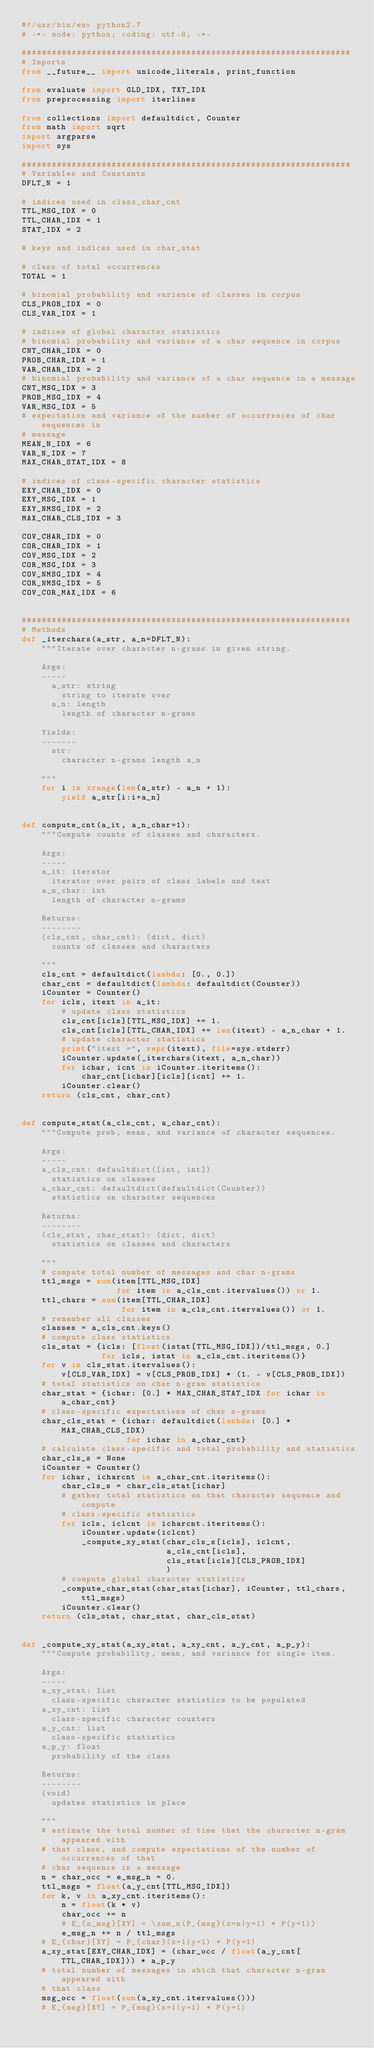<code> <loc_0><loc_0><loc_500><loc_500><_Python_>#!/usr/bin/env python2.7
# -*- mode: python; coding: utf-8; -*-

##################################################################
# Imports
from __future__ import unicode_literals, print_function

from evaluate import GLD_IDX, TXT_IDX
from preprocessing import iterlines

from collections import defaultdict, Counter
from math import sqrt
import argparse
import sys

##################################################################
# Variables and Constants
DFLT_N = 1

# indices used in class_char_cnt
TTL_MSG_IDX = 0
TTL_CHAR_IDX = 1
STAT_IDX = 2

# keys and indices used in char_stat

# class of total occurrences
TOTAL = 1

# binomial probability and variance of classes in corpus
CLS_PROB_IDX = 0
CLS_VAR_IDX = 1

# indices of global character statistics
# binomial probability and variance of a char sequence in corpus
CNT_CHAR_IDX = 0
PROB_CHAR_IDX = 1
VAR_CHAR_IDX = 2
# binomial probability and variance of a char sequence in a message
CNT_MSG_IDX = 3
PROB_MSG_IDX = 4
VAR_MSG_IDX = 5
# expectation and variance of the number of occurrences of char sequences in
# message
MEAN_N_IDX = 6
VAR_N_IDX = 7
MAX_CHAR_STAT_IDX = 8

# indices of class-specific character statistics
EXY_CHAR_IDX = 0
EXY_MSG_IDX = 1
EXY_NMSG_IDX = 2
MAX_CHAR_CLS_IDX = 3

COV_CHAR_IDX = 0
COR_CHAR_IDX = 1
COV_MSG_IDX = 2
COR_MSG_IDX = 3
COV_NMSG_IDX = 4
COR_NMSG_IDX = 5
COV_COR_MAX_IDX = 6


##################################################################
# Methods
def _iterchars(a_str, a_n=DFLT_N):
    """Iterate over character n-grams in given string.

    Args:
    -----
      a_str: string
        string to iterate over
      a_n: length
        length of character n-grams

    Yields:
    -------
      str:
        character n-grams length a_n

    """
    for i in xrange(len(a_str) - a_n + 1):
        yield a_str[i:i+a_n]


def compute_cnt(a_it, a_n_char=1):
    """Compute counts of classes and characters.

    Args:
    -----
    a_it: iterator
      iterator over pairs of class labels and text
    a_n_char: int
      length of character n-grams

    Returns:
    --------
    (cls_cnt, char_cnt): (dict, dict)
      counts of classes and characters

    """
    cls_cnt = defaultdict(lambda: [0., 0.])
    char_cnt = defaultdict(lambda: defaultdict(Counter))
    iCounter = Counter()
    for icls, itext in a_it:
        # update class statistics
        cls_cnt[icls][TTL_MSG_IDX] += 1.
        cls_cnt[icls][TTL_CHAR_IDX] += len(itext) - a_n_char + 1.
        # update character statistics
        print("itext =", repr(itext), file=sys.stderr)
        iCounter.update(_iterchars(itext, a_n_char))
        for ichar, icnt in iCounter.iteritems():
            char_cnt[ichar][icls][icnt] += 1.
        iCounter.clear()
    return (cls_cnt, char_cnt)


def compute_stat(a_cls_cnt, a_char_cnt):
    """Compute prob, mean, and variance of character sequences.

    Args:
    -----
    a_cls_cnt: defaultdict([int, int])
      statistics on classes
    a_char_cnt: defaultdict(defaultdict(Counter))
      statistics on character sequences

    Returns:
    --------
    (cls_stat, char_stat): (dict, dict)
      statistics on classes and characters

    """
    # compute total number of messages and char n-grams
    ttl_msgs = sum(item[TTL_MSG_IDX]
                   for item in a_cls_cnt.itervalues()) or 1.
    ttl_chars = sum(item[TTL_CHAR_IDX]
                    for item in a_cls_cnt.itervalues()) or 1.
    # remember all classes
    classes = a_cls_cnt.keys()
    # compute class statistics
    cls_stat = {icls: [float(istat[TTL_MSG_IDX])/ttl_msgs, 0.]
                for icls, istat in a_cls_cnt.iteritems()}
    for v in cls_stat.itervalues():
        v[CLS_VAR_IDX] = v[CLS_PROB_IDX] * (1. - v[CLS_PROB_IDX])
    # total statistics on char n-gram statistics
    char_stat = {ichar: [0.] * MAX_CHAR_STAT_IDX for ichar in a_char_cnt}
    # class-specific expectations of char n-grams
    char_cls_stat = {ichar: defaultdict(lambda: [0.] * MAX_CHAR_CLS_IDX)
                     for ichar in a_char_cnt}
    # calculate class-specific and total probability and statistics
    char_cls_s = None
    iCounter = Counter()
    for ichar, icharcnt in a_char_cnt.iteritems():
        char_cls_s = char_cls_stat[ichar]
        # gather total statistics on that character sequence and compute
        # class-specific statistics
        for icls, iclcnt in icharcnt.iteritems():
            iCounter.update(iclcnt)
            _compute_xy_stat(char_cls_s[icls], iclcnt,
                             a_cls_cnt[icls],
                             cls_stat[icls][CLS_PROB_IDX]
                             )
        # compute global character statistics
        _compute_char_stat(char_stat[ichar], iCounter, ttl_chars, ttl_msgs)
        iCounter.clear()
    return (cls_stat, char_stat, char_cls_stat)


def _compute_xy_stat(a_xy_stat, a_xy_cnt, a_y_cnt, a_p_y):
    """Compute probability, mean, and variance for single item.

    Args:
    -----
    a_xy_stat: list
      class-specific character statistics to be populated
    a_xy_cnt: list
      class-specific character counters
    a_y_cnt: list
      class-specific statistics
    a_p_y: float
      probability of the class

    Returns:
    --------
    (void)
      updates statistics in place

    """
    # estimate the total number of time that the character n-gram appeared with
    # that class, and compute expectations of the number of occurrences of that
    # char sequence in a message
    n = char_occ = e_msg_n = 0.
    ttl_msgs = float(a_y_cnt[TTL_MSG_IDX])
    for k, v in a_xy_cnt.iteritems():
        n = float(k * v)
        char_occ += n
        # E_{n_msg}[XY] = \sum_n(P_{msg}(x=n|y=1) * P(y=1))
        e_msg_n += n / ttl_msgs
    # E_{char}[XY] = P_{char}(x=1|y=1) * P(y=1)
    a_xy_stat[EXY_CHAR_IDX] = (char_occ / float(a_y_cnt[TTL_CHAR_IDX])) * a_p_y
    # total number of messages in which that character n-gram appeared with
    # that class
    msg_occ = float(sum(a_xy_cnt.itervalues()))
    # E_{msg}[XY] = P_{msg}(x=1|y=1) * P(y=1)</code> 